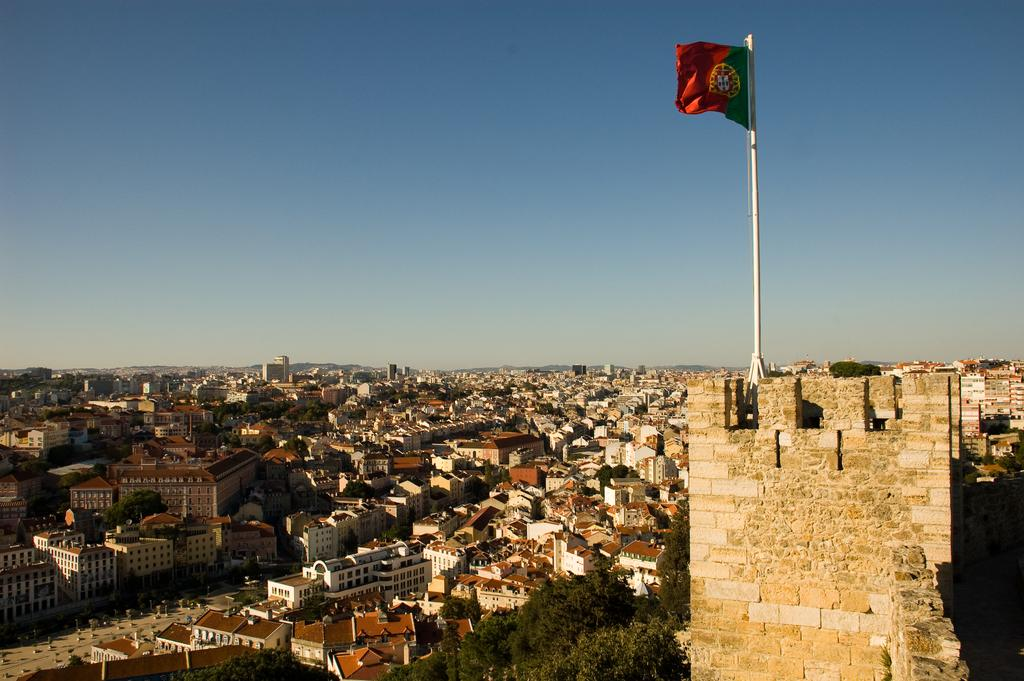What type of structures can be seen in the image? There are houses and buildings in the image. What else can be seen in the image besides structures? There are trees and a flagpole in the image. Are there any vehicles visible in the image? Yes, there are vehicles on the road in the image. What is visible in the sky in the image? The sky is visible in the image. What can be inferred about the weather based on the image? The image appears to have been taken during a sunny day. What type of trail can be seen in the image? There is no trail present in the image. What sign is visible on the buildings in the image? There are no signs visible on the buildings in the image. 